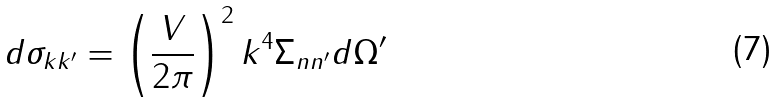Convert formula to latex. <formula><loc_0><loc_0><loc_500><loc_500>d \sigma _ { k k ^ { \prime } } = \left ( \frac { V } { 2 \pi } \right ) ^ { 2 } k ^ { 4 } \Sigma _ { n n ^ { \prime } } d \Omega ^ { \prime }</formula> 